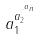Convert formula to latex. <formula><loc_0><loc_0><loc_500><loc_500>a _ { 1 } ^ { a _ { 2 } ^ { \cdot ^ { \cdot ^ { a _ { n } } } } }</formula> 